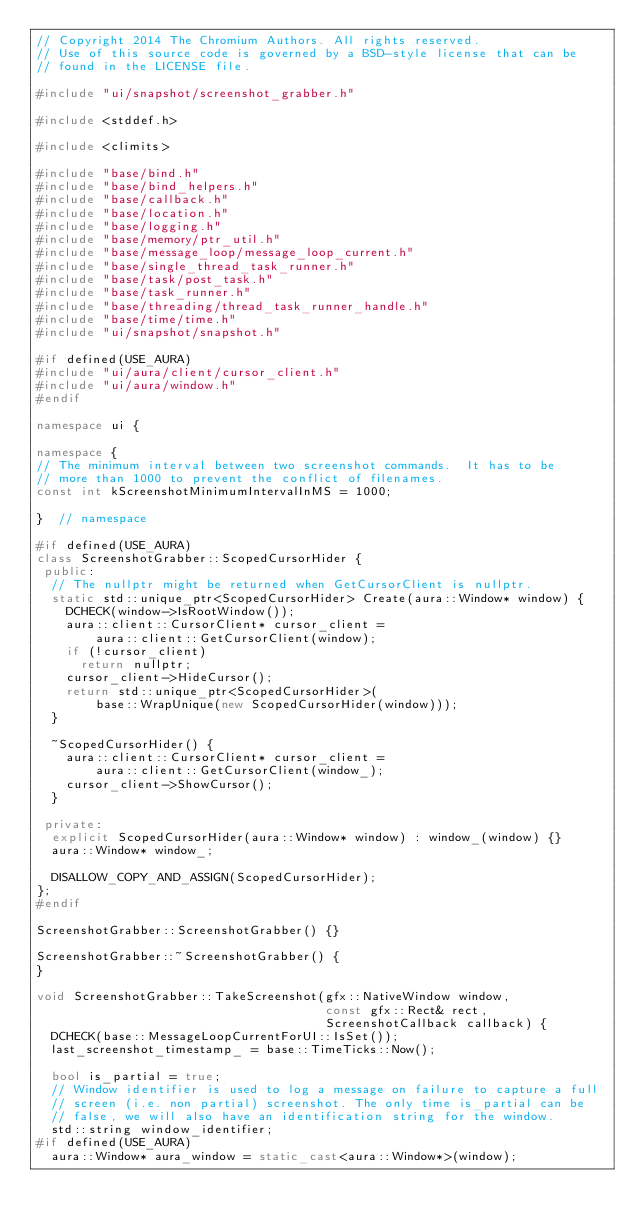Convert code to text. <code><loc_0><loc_0><loc_500><loc_500><_C++_>// Copyright 2014 The Chromium Authors. All rights reserved.
// Use of this source code is governed by a BSD-style license that can be
// found in the LICENSE file.

#include "ui/snapshot/screenshot_grabber.h"

#include <stddef.h>

#include <climits>

#include "base/bind.h"
#include "base/bind_helpers.h"
#include "base/callback.h"
#include "base/location.h"
#include "base/logging.h"
#include "base/memory/ptr_util.h"
#include "base/message_loop/message_loop_current.h"
#include "base/single_thread_task_runner.h"
#include "base/task/post_task.h"
#include "base/task_runner.h"
#include "base/threading/thread_task_runner_handle.h"
#include "base/time/time.h"
#include "ui/snapshot/snapshot.h"

#if defined(USE_AURA)
#include "ui/aura/client/cursor_client.h"
#include "ui/aura/window.h"
#endif

namespace ui {

namespace {
// The minimum interval between two screenshot commands.  It has to be
// more than 1000 to prevent the conflict of filenames.
const int kScreenshotMinimumIntervalInMS = 1000;

}  // namespace

#if defined(USE_AURA)
class ScreenshotGrabber::ScopedCursorHider {
 public:
  // The nullptr might be returned when GetCursorClient is nullptr.
  static std::unique_ptr<ScopedCursorHider> Create(aura::Window* window) {
    DCHECK(window->IsRootWindow());
    aura::client::CursorClient* cursor_client =
        aura::client::GetCursorClient(window);
    if (!cursor_client)
      return nullptr;
    cursor_client->HideCursor();
    return std::unique_ptr<ScopedCursorHider>(
        base::WrapUnique(new ScopedCursorHider(window)));
  }

  ~ScopedCursorHider() {
    aura::client::CursorClient* cursor_client =
        aura::client::GetCursorClient(window_);
    cursor_client->ShowCursor();
  }

 private:
  explicit ScopedCursorHider(aura::Window* window) : window_(window) {}
  aura::Window* window_;

  DISALLOW_COPY_AND_ASSIGN(ScopedCursorHider);
};
#endif

ScreenshotGrabber::ScreenshotGrabber() {}

ScreenshotGrabber::~ScreenshotGrabber() {
}

void ScreenshotGrabber::TakeScreenshot(gfx::NativeWindow window,
                                       const gfx::Rect& rect,
                                       ScreenshotCallback callback) {
  DCHECK(base::MessageLoopCurrentForUI::IsSet());
  last_screenshot_timestamp_ = base::TimeTicks::Now();

  bool is_partial = true;
  // Window identifier is used to log a message on failure to capture a full
  // screen (i.e. non partial) screenshot. The only time is_partial can be
  // false, we will also have an identification string for the window.
  std::string window_identifier;
#if defined(USE_AURA)
  aura::Window* aura_window = static_cast<aura::Window*>(window);</code> 